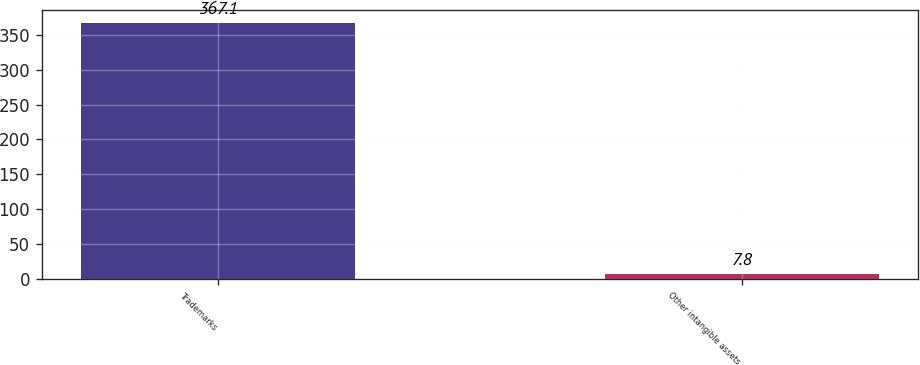Convert chart to OTSL. <chart><loc_0><loc_0><loc_500><loc_500><bar_chart><fcel>Trademarks<fcel>Other intangible assets<nl><fcel>367.1<fcel>7.8<nl></chart> 